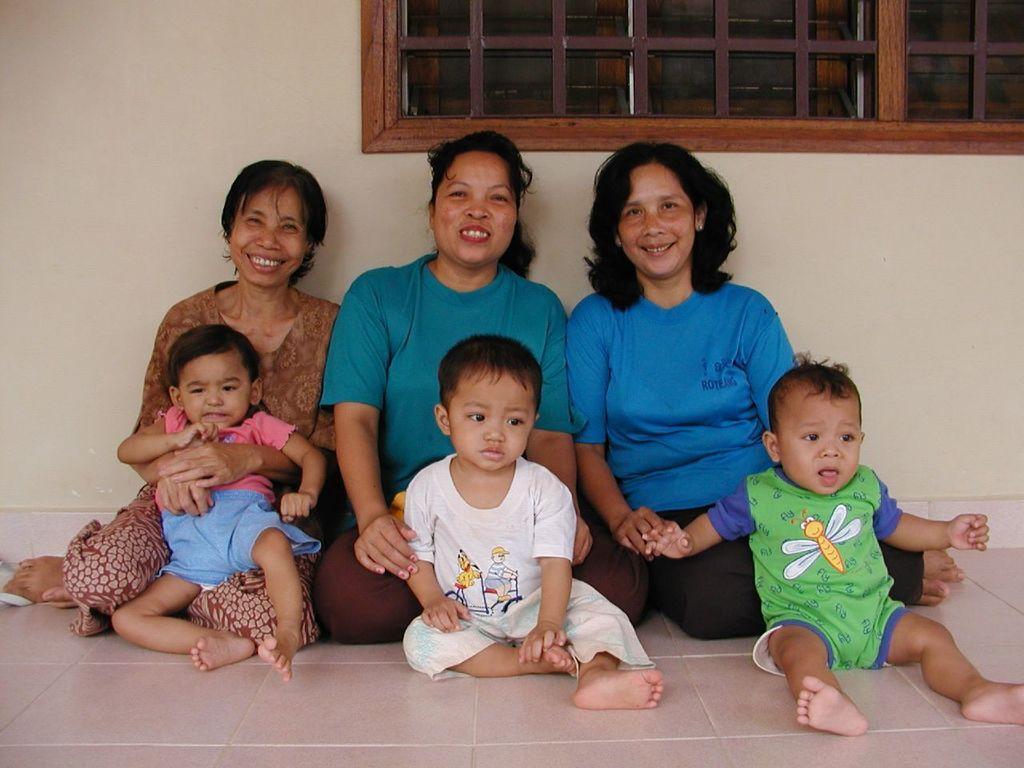How would you summarize this image in a sentence or two? This image consists of 3 women and 3 children. Women are smiling. All of them are sitting on the floor. 